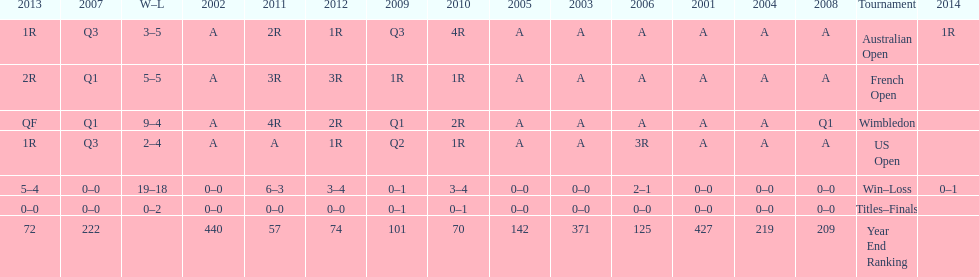What tournament has 5-5 as it's "w-l" record? French Open. 